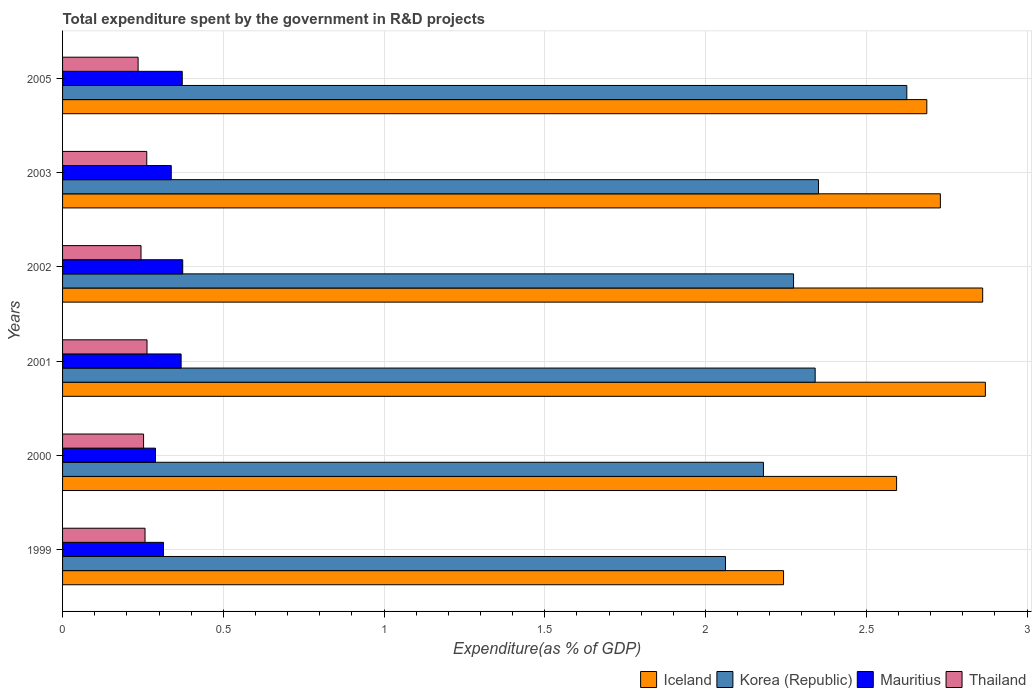How many groups of bars are there?
Offer a very short reply. 6. Are the number of bars per tick equal to the number of legend labels?
Offer a terse response. Yes. How many bars are there on the 1st tick from the top?
Your answer should be very brief. 4. How many bars are there on the 6th tick from the bottom?
Give a very brief answer. 4. What is the label of the 1st group of bars from the top?
Offer a terse response. 2005. In how many cases, is the number of bars for a given year not equal to the number of legend labels?
Give a very brief answer. 0. What is the total expenditure spent by the government in R&D projects in Iceland in 2003?
Provide a short and direct response. 2.73. Across all years, what is the maximum total expenditure spent by the government in R&D projects in Iceland?
Keep it short and to the point. 2.87. Across all years, what is the minimum total expenditure spent by the government in R&D projects in Thailand?
Provide a short and direct response. 0.23. In which year was the total expenditure spent by the government in R&D projects in Korea (Republic) minimum?
Provide a short and direct response. 1999. What is the total total expenditure spent by the government in R&D projects in Iceland in the graph?
Provide a succinct answer. 15.99. What is the difference between the total expenditure spent by the government in R&D projects in Korea (Republic) in 2001 and that in 2005?
Keep it short and to the point. -0.29. What is the difference between the total expenditure spent by the government in R&D projects in Thailand in 1999 and the total expenditure spent by the government in R&D projects in Korea (Republic) in 2002?
Provide a succinct answer. -2.02. What is the average total expenditure spent by the government in R&D projects in Mauritius per year?
Make the answer very short. 0.34. In the year 2000, what is the difference between the total expenditure spent by the government in R&D projects in Korea (Republic) and total expenditure spent by the government in R&D projects in Mauritius?
Make the answer very short. 1.89. In how many years, is the total expenditure spent by the government in R&D projects in Korea (Republic) greater than 1.3 %?
Keep it short and to the point. 6. What is the ratio of the total expenditure spent by the government in R&D projects in Thailand in 1999 to that in 2002?
Provide a short and direct response. 1.05. Is the total expenditure spent by the government in R&D projects in Korea (Republic) in 1999 less than that in 2005?
Give a very brief answer. Yes. Is the difference between the total expenditure spent by the government in R&D projects in Korea (Republic) in 2001 and 2002 greater than the difference between the total expenditure spent by the government in R&D projects in Mauritius in 2001 and 2002?
Your answer should be compact. Yes. What is the difference between the highest and the second highest total expenditure spent by the government in R&D projects in Mauritius?
Give a very brief answer. 0. What is the difference between the highest and the lowest total expenditure spent by the government in R&D projects in Iceland?
Provide a short and direct response. 0.63. Is the sum of the total expenditure spent by the government in R&D projects in Korea (Republic) in 2000 and 2002 greater than the maximum total expenditure spent by the government in R&D projects in Mauritius across all years?
Give a very brief answer. Yes. What does the 1st bar from the top in 1999 represents?
Offer a very short reply. Thailand. What does the 2nd bar from the bottom in 2002 represents?
Offer a terse response. Korea (Republic). Is it the case that in every year, the sum of the total expenditure spent by the government in R&D projects in Iceland and total expenditure spent by the government in R&D projects in Thailand is greater than the total expenditure spent by the government in R&D projects in Mauritius?
Your response must be concise. Yes. How many bars are there?
Provide a succinct answer. 24. How many years are there in the graph?
Offer a very short reply. 6. What is the difference between two consecutive major ticks on the X-axis?
Your answer should be compact. 0.5. Does the graph contain grids?
Your answer should be compact. Yes. What is the title of the graph?
Provide a short and direct response. Total expenditure spent by the government in R&D projects. Does "Barbados" appear as one of the legend labels in the graph?
Provide a succinct answer. No. What is the label or title of the X-axis?
Your response must be concise. Expenditure(as % of GDP). What is the label or title of the Y-axis?
Your answer should be compact. Years. What is the Expenditure(as % of GDP) in Iceland in 1999?
Your response must be concise. 2.24. What is the Expenditure(as % of GDP) in Korea (Republic) in 1999?
Give a very brief answer. 2.06. What is the Expenditure(as % of GDP) in Mauritius in 1999?
Make the answer very short. 0.31. What is the Expenditure(as % of GDP) in Thailand in 1999?
Offer a terse response. 0.26. What is the Expenditure(as % of GDP) in Iceland in 2000?
Give a very brief answer. 2.59. What is the Expenditure(as % of GDP) of Korea (Republic) in 2000?
Ensure brevity in your answer.  2.18. What is the Expenditure(as % of GDP) of Mauritius in 2000?
Your response must be concise. 0.29. What is the Expenditure(as % of GDP) of Thailand in 2000?
Ensure brevity in your answer.  0.25. What is the Expenditure(as % of GDP) in Iceland in 2001?
Your answer should be compact. 2.87. What is the Expenditure(as % of GDP) in Korea (Republic) in 2001?
Keep it short and to the point. 2.34. What is the Expenditure(as % of GDP) in Mauritius in 2001?
Offer a terse response. 0.37. What is the Expenditure(as % of GDP) of Thailand in 2001?
Your answer should be compact. 0.26. What is the Expenditure(as % of GDP) in Iceland in 2002?
Provide a short and direct response. 2.86. What is the Expenditure(as % of GDP) in Korea (Republic) in 2002?
Provide a succinct answer. 2.27. What is the Expenditure(as % of GDP) of Mauritius in 2002?
Your answer should be compact. 0.37. What is the Expenditure(as % of GDP) in Thailand in 2002?
Your answer should be compact. 0.24. What is the Expenditure(as % of GDP) in Iceland in 2003?
Offer a very short reply. 2.73. What is the Expenditure(as % of GDP) of Korea (Republic) in 2003?
Your answer should be very brief. 2.35. What is the Expenditure(as % of GDP) in Mauritius in 2003?
Ensure brevity in your answer.  0.34. What is the Expenditure(as % of GDP) of Thailand in 2003?
Ensure brevity in your answer.  0.26. What is the Expenditure(as % of GDP) in Iceland in 2005?
Keep it short and to the point. 2.69. What is the Expenditure(as % of GDP) in Korea (Republic) in 2005?
Your response must be concise. 2.63. What is the Expenditure(as % of GDP) in Mauritius in 2005?
Your answer should be compact. 0.37. What is the Expenditure(as % of GDP) in Thailand in 2005?
Provide a succinct answer. 0.23. Across all years, what is the maximum Expenditure(as % of GDP) of Iceland?
Your response must be concise. 2.87. Across all years, what is the maximum Expenditure(as % of GDP) in Korea (Republic)?
Your answer should be compact. 2.63. Across all years, what is the maximum Expenditure(as % of GDP) of Mauritius?
Keep it short and to the point. 0.37. Across all years, what is the maximum Expenditure(as % of GDP) in Thailand?
Keep it short and to the point. 0.26. Across all years, what is the minimum Expenditure(as % of GDP) of Iceland?
Ensure brevity in your answer.  2.24. Across all years, what is the minimum Expenditure(as % of GDP) in Korea (Republic)?
Offer a very short reply. 2.06. Across all years, what is the minimum Expenditure(as % of GDP) of Mauritius?
Keep it short and to the point. 0.29. Across all years, what is the minimum Expenditure(as % of GDP) of Thailand?
Offer a terse response. 0.23. What is the total Expenditure(as % of GDP) of Iceland in the graph?
Ensure brevity in your answer.  15.99. What is the total Expenditure(as % of GDP) in Korea (Republic) in the graph?
Ensure brevity in your answer.  13.83. What is the total Expenditure(as % of GDP) of Mauritius in the graph?
Provide a succinct answer. 2.06. What is the total Expenditure(as % of GDP) of Thailand in the graph?
Your answer should be very brief. 1.51. What is the difference between the Expenditure(as % of GDP) in Iceland in 1999 and that in 2000?
Ensure brevity in your answer.  -0.35. What is the difference between the Expenditure(as % of GDP) in Korea (Republic) in 1999 and that in 2000?
Ensure brevity in your answer.  -0.12. What is the difference between the Expenditure(as % of GDP) in Mauritius in 1999 and that in 2000?
Provide a short and direct response. 0.02. What is the difference between the Expenditure(as % of GDP) of Thailand in 1999 and that in 2000?
Make the answer very short. 0. What is the difference between the Expenditure(as % of GDP) in Iceland in 1999 and that in 2001?
Keep it short and to the point. -0.63. What is the difference between the Expenditure(as % of GDP) in Korea (Republic) in 1999 and that in 2001?
Make the answer very short. -0.28. What is the difference between the Expenditure(as % of GDP) of Mauritius in 1999 and that in 2001?
Provide a succinct answer. -0.05. What is the difference between the Expenditure(as % of GDP) in Thailand in 1999 and that in 2001?
Offer a very short reply. -0.01. What is the difference between the Expenditure(as % of GDP) of Iceland in 1999 and that in 2002?
Your answer should be compact. -0.62. What is the difference between the Expenditure(as % of GDP) in Korea (Republic) in 1999 and that in 2002?
Your answer should be very brief. -0.21. What is the difference between the Expenditure(as % of GDP) of Mauritius in 1999 and that in 2002?
Keep it short and to the point. -0.06. What is the difference between the Expenditure(as % of GDP) in Thailand in 1999 and that in 2002?
Provide a succinct answer. 0.01. What is the difference between the Expenditure(as % of GDP) in Iceland in 1999 and that in 2003?
Your answer should be compact. -0.49. What is the difference between the Expenditure(as % of GDP) in Korea (Republic) in 1999 and that in 2003?
Your answer should be compact. -0.29. What is the difference between the Expenditure(as % of GDP) in Mauritius in 1999 and that in 2003?
Your response must be concise. -0.02. What is the difference between the Expenditure(as % of GDP) of Thailand in 1999 and that in 2003?
Ensure brevity in your answer.  -0.01. What is the difference between the Expenditure(as % of GDP) in Iceland in 1999 and that in 2005?
Provide a short and direct response. -0.45. What is the difference between the Expenditure(as % of GDP) in Korea (Republic) in 1999 and that in 2005?
Offer a terse response. -0.56. What is the difference between the Expenditure(as % of GDP) in Mauritius in 1999 and that in 2005?
Your response must be concise. -0.06. What is the difference between the Expenditure(as % of GDP) of Thailand in 1999 and that in 2005?
Provide a succinct answer. 0.02. What is the difference between the Expenditure(as % of GDP) of Iceland in 2000 and that in 2001?
Provide a short and direct response. -0.28. What is the difference between the Expenditure(as % of GDP) of Korea (Republic) in 2000 and that in 2001?
Give a very brief answer. -0.16. What is the difference between the Expenditure(as % of GDP) of Mauritius in 2000 and that in 2001?
Offer a terse response. -0.08. What is the difference between the Expenditure(as % of GDP) in Thailand in 2000 and that in 2001?
Provide a short and direct response. -0.01. What is the difference between the Expenditure(as % of GDP) of Iceland in 2000 and that in 2002?
Provide a short and direct response. -0.27. What is the difference between the Expenditure(as % of GDP) in Korea (Republic) in 2000 and that in 2002?
Provide a succinct answer. -0.09. What is the difference between the Expenditure(as % of GDP) of Mauritius in 2000 and that in 2002?
Give a very brief answer. -0.08. What is the difference between the Expenditure(as % of GDP) of Thailand in 2000 and that in 2002?
Provide a short and direct response. 0.01. What is the difference between the Expenditure(as % of GDP) of Iceland in 2000 and that in 2003?
Make the answer very short. -0.14. What is the difference between the Expenditure(as % of GDP) in Korea (Republic) in 2000 and that in 2003?
Keep it short and to the point. -0.17. What is the difference between the Expenditure(as % of GDP) in Mauritius in 2000 and that in 2003?
Make the answer very short. -0.05. What is the difference between the Expenditure(as % of GDP) of Thailand in 2000 and that in 2003?
Offer a terse response. -0.01. What is the difference between the Expenditure(as % of GDP) of Iceland in 2000 and that in 2005?
Your answer should be compact. -0.09. What is the difference between the Expenditure(as % of GDP) in Korea (Republic) in 2000 and that in 2005?
Make the answer very short. -0.45. What is the difference between the Expenditure(as % of GDP) of Mauritius in 2000 and that in 2005?
Give a very brief answer. -0.08. What is the difference between the Expenditure(as % of GDP) of Thailand in 2000 and that in 2005?
Your answer should be compact. 0.02. What is the difference between the Expenditure(as % of GDP) of Iceland in 2001 and that in 2002?
Your answer should be compact. 0.01. What is the difference between the Expenditure(as % of GDP) of Korea (Republic) in 2001 and that in 2002?
Make the answer very short. 0.07. What is the difference between the Expenditure(as % of GDP) in Mauritius in 2001 and that in 2002?
Offer a very short reply. -0.01. What is the difference between the Expenditure(as % of GDP) of Thailand in 2001 and that in 2002?
Your response must be concise. 0.02. What is the difference between the Expenditure(as % of GDP) of Iceland in 2001 and that in 2003?
Keep it short and to the point. 0.14. What is the difference between the Expenditure(as % of GDP) in Korea (Republic) in 2001 and that in 2003?
Your response must be concise. -0.01. What is the difference between the Expenditure(as % of GDP) of Mauritius in 2001 and that in 2003?
Provide a short and direct response. 0.03. What is the difference between the Expenditure(as % of GDP) in Thailand in 2001 and that in 2003?
Offer a terse response. 0. What is the difference between the Expenditure(as % of GDP) of Iceland in 2001 and that in 2005?
Make the answer very short. 0.18. What is the difference between the Expenditure(as % of GDP) of Korea (Republic) in 2001 and that in 2005?
Give a very brief answer. -0.29. What is the difference between the Expenditure(as % of GDP) in Mauritius in 2001 and that in 2005?
Provide a succinct answer. -0. What is the difference between the Expenditure(as % of GDP) in Thailand in 2001 and that in 2005?
Provide a succinct answer. 0.03. What is the difference between the Expenditure(as % of GDP) in Iceland in 2002 and that in 2003?
Your answer should be compact. 0.13. What is the difference between the Expenditure(as % of GDP) in Korea (Republic) in 2002 and that in 2003?
Keep it short and to the point. -0.08. What is the difference between the Expenditure(as % of GDP) of Mauritius in 2002 and that in 2003?
Provide a succinct answer. 0.04. What is the difference between the Expenditure(as % of GDP) of Thailand in 2002 and that in 2003?
Provide a short and direct response. -0.02. What is the difference between the Expenditure(as % of GDP) of Iceland in 2002 and that in 2005?
Keep it short and to the point. 0.17. What is the difference between the Expenditure(as % of GDP) of Korea (Republic) in 2002 and that in 2005?
Provide a succinct answer. -0.35. What is the difference between the Expenditure(as % of GDP) of Mauritius in 2002 and that in 2005?
Offer a very short reply. 0. What is the difference between the Expenditure(as % of GDP) of Thailand in 2002 and that in 2005?
Keep it short and to the point. 0.01. What is the difference between the Expenditure(as % of GDP) in Iceland in 2003 and that in 2005?
Make the answer very short. 0.04. What is the difference between the Expenditure(as % of GDP) in Korea (Republic) in 2003 and that in 2005?
Ensure brevity in your answer.  -0.27. What is the difference between the Expenditure(as % of GDP) in Mauritius in 2003 and that in 2005?
Provide a short and direct response. -0.03. What is the difference between the Expenditure(as % of GDP) of Thailand in 2003 and that in 2005?
Give a very brief answer. 0.03. What is the difference between the Expenditure(as % of GDP) in Iceland in 1999 and the Expenditure(as % of GDP) in Korea (Republic) in 2000?
Keep it short and to the point. 0.06. What is the difference between the Expenditure(as % of GDP) of Iceland in 1999 and the Expenditure(as % of GDP) of Mauritius in 2000?
Offer a very short reply. 1.95. What is the difference between the Expenditure(as % of GDP) in Iceland in 1999 and the Expenditure(as % of GDP) in Thailand in 2000?
Ensure brevity in your answer.  1.99. What is the difference between the Expenditure(as % of GDP) in Korea (Republic) in 1999 and the Expenditure(as % of GDP) in Mauritius in 2000?
Offer a terse response. 1.77. What is the difference between the Expenditure(as % of GDP) in Korea (Republic) in 1999 and the Expenditure(as % of GDP) in Thailand in 2000?
Keep it short and to the point. 1.81. What is the difference between the Expenditure(as % of GDP) in Mauritius in 1999 and the Expenditure(as % of GDP) in Thailand in 2000?
Make the answer very short. 0.06. What is the difference between the Expenditure(as % of GDP) of Iceland in 1999 and the Expenditure(as % of GDP) of Korea (Republic) in 2001?
Give a very brief answer. -0.1. What is the difference between the Expenditure(as % of GDP) in Iceland in 1999 and the Expenditure(as % of GDP) in Mauritius in 2001?
Provide a short and direct response. 1.87. What is the difference between the Expenditure(as % of GDP) in Iceland in 1999 and the Expenditure(as % of GDP) in Thailand in 2001?
Ensure brevity in your answer.  1.98. What is the difference between the Expenditure(as % of GDP) in Korea (Republic) in 1999 and the Expenditure(as % of GDP) in Mauritius in 2001?
Your answer should be very brief. 1.69. What is the difference between the Expenditure(as % of GDP) in Korea (Republic) in 1999 and the Expenditure(as % of GDP) in Thailand in 2001?
Offer a very short reply. 1.8. What is the difference between the Expenditure(as % of GDP) in Mauritius in 1999 and the Expenditure(as % of GDP) in Thailand in 2001?
Keep it short and to the point. 0.05. What is the difference between the Expenditure(as % of GDP) of Iceland in 1999 and the Expenditure(as % of GDP) of Korea (Republic) in 2002?
Ensure brevity in your answer.  -0.03. What is the difference between the Expenditure(as % of GDP) of Iceland in 1999 and the Expenditure(as % of GDP) of Mauritius in 2002?
Offer a very short reply. 1.87. What is the difference between the Expenditure(as % of GDP) of Iceland in 1999 and the Expenditure(as % of GDP) of Thailand in 2002?
Ensure brevity in your answer.  2. What is the difference between the Expenditure(as % of GDP) of Korea (Republic) in 1999 and the Expenditure(as % of GDP) of Mauritius in 2002?
Provide a succinct answer. 1.69. What is the difference between the Expenditure(as % of GDP) in Korea (Republic) in 1999 and the Expenditure(as % of GDP) in Thailand in 2002?
Give a very brief answer. 1.82. What is the difference between the Expenditure(as % of GDP) in Mauritius in 1999 and the Expenditure(as % of GDP) in Thailand in 2002?
Offer a very short reply. 0.07. What is the difference between the Expenditure(as % of GDP) in Iceland in 1999 and the Expenditure(as % of GDP) in Korea (Republic) in 2003?
Keep it short and to the point. -0.11. What is the difference between the Expenditure(as % of GDP) of Iceland in 1999 and the Expenditure(as % of GDP) of Mauritius in 2003?
Offer a terse response. 1.9. What is the difference between the Expenditure(as % of GDP) in Iceland in 1999 and the Expenditure(as % of GDP) in Thailand in 2003?
Your answer should be very brief. 1.98. What is the difference between the Expenditure(as % of GDP) in Korea (Republic) in 1999 and the Expenditure(as % of GDP) in Mauritius in 2003?
Your answer should be compact. 1.72. What is the difference between the Expenditure(as % of GDP) in Korea (Republic) in 1999 and the Expenditure(as % of GDP) in Thailand in 2003?
Keep it short and to the point. 1.8. What is the difference between the Expenditure(as % of GDP) in Mauritius in 1999 and the Expenditure(as % of GDP) in Thailand in 2003?
Your response must be concise. 0.05. What is the difference between the Expenditure(as % of GDP) of Iceland in 1999 and the Expenditure(as % of GDP) of Korea (Republic) in 2005?
Offer a terse response. -0.38. What is the difference between the Expenditure(as % of GDP) in Iceland in 1999 and the Expenditure(as % of GDP) in Mauritius in 2005?
Your answer should be compact. 1.87. What is the difference between the Expenditure(as % of GDP) of Iceland in 1999 and the Expenditure(as % of GDP) of Thailand in 2005?
Offer a very short reply. 2.01. What is the difference between the Expenditure(as % of GDP) of Korea (Republic) in 1999 and the Expenditure(as % of GDP) of Mauritius in 2005?
Offer a terse response. 1.69. What is the difference between the Expenditure(as % of GDP) of Korea (Republic) in 1999 and the Expenditure(as % of GDP) of Thailand in 2005?
Ensure brevity in your answer.  1.83. What is the difference between the Expenditure(as % of GDP) in Mauritius in 1999 and the Expenditure(as % of GDP) in Thailand in 2005?
Your answer should be very brief. 0.08. What is the difference between the Expenditure(as % of GDP) in Iceland in 2000 and the Expenditure(as % of GDP) in Korea (Republic) in 2001?
Ensure brevity in your answer.  0.25. What is the difference between the Expenditure(as % of GDP) of Iceland in 2000 and the Expenditure(as % of GDP) of Mauritius in 2001?
Provide a short and direct response. 2.23. What is the difference between the Expenditure(as % of GDP) in Iceland in 2000 and the Expenditure(as % of GDP) in Thailand in 2001?
Your answer should be very brief. 2.33. What is the difference between the Expenditure(as % of GDP) of Korea (Republic) in 2000 and the Expenditure(as % of GDP) of Mauritius in 2001?
Your answer should be compact. 1.81. What is the difference between the Expenditure(as % of GDP) in Korea (Republic) in 2000 and the Expenditure(as % of GDP) in Thailand in 2001?
Ensure brevity in your answer.  1.92. What is the difference between the Expenditure(as % of GDP) in Mauritius in 2000 and the Expenditure(as % of GDP) in Thailand in 2001?
Your response must be concise. 0.03. What is the difference between the Expenditure(as % of GDP) of Iceland in 2000 and the Expenditure(as % of GDP) of Korea (Republic) in 2002?
Offer a terse response. 0.32. What is the difference between the Expenditure(as % of GDP) of Iceland in 2000 and the Expenditure(as % of GDP) of Mauritius in 2002?
Keep it short and to the point. 2.22. What is the difference between the Expenditure(as % of GDP) of Iceland in 2000 and the Expenditure(as % of GDP) of Thailand in 2002?
Give a very brief answer. 2.35. What is the difference between the Expenditure(as % of GDP) of Korea (Republic) in 2000 and the Expenditure(as % of GDP) of Mauritius in 2002?
Your response must be concise. 1.81. What is the difference between the Expenditure(as % of GDP) of Korea (Republic) in 2000 and the Expenditure(as % of GDP) of Thailand in 2002?
Provide a succinct answer. 1.94. What is the difference between the Expenditure(as % of GDP) of Mauritius in 2000 and the Expenditure(as % of GDP) of Thailand in 2002?
Provide a succinct answer. 0.04. What is the difference between the Expenditure(as % of GDP) of Iceland in 2000 and the Expenditure(as % of GDP) of Korea (Republic) in 2003?
Your answer should be compact. 0.24. What is the difference between the Expenditure(as % of GDP) in Iceland in 2000 and the Expenditure(as % of GDP) in Mauritius in 2003?
Your response must be concise. 2.26. What is the difference between the Expenditure(as % of GDP) of Iceland in 2000 and the Expenditure(as % of GDP) of Thailand in 2003?
Your answer should be very brief. 2.33. What is the difference between the Expenditure(as % of GDP) of Korea (Republic) in 2000 and the Expenditure(as % of GDP) of Mauritius in 2003?
Your answer should be very brief. 1.84. What is the difference between the Expenditure(as % of GDP) in Korea (Republic) in 2000 and the Expenditure(as % of GDP) in Thailand in 2003?
Your answer should be very brief. 1.92. What is the difference between the Expenditure(as % of GDP) in Mauritius in 2000 and the Expenditure(as % of GDP) in Thailand in 2003?
Make the answer very short. 0.03. What is the difference between the Expenditure(as % of GDP) in Iceland in 2000 and the Expenditure(as % of GDP) in Korea (Republic) in 2005?
Your answer should be compact. -0.03. What is the difference between the Expenditure(as % of GDP) in Iceland in 2000 and the Expenditure(as % of GDP) in Mauritius in 2005?
Offer a terse response. 2.22. What is the difference between the Expenditure(as % of GDP) of Iceland in 2000 and the Expenditure(as % of GDP) of Thailand in 2005?
Make the answer very short. 2.36. What is the difference between the Expenditure(as % of GDP) in Korea (Republic) in 2000 and the Expenditure(as % of GDP) in Mauritius in 2005?
Provide a succinct answer. 1.81. What is the difference between the Expenditure(as % of GDP) of Korea (Republic) in 2000 and the Expenditure(as % of GDP) of Thailand in 2005?
Offer a very short reply. 1.95. What is the difference between the Expenditure(as % of GDP) of Mauritius in 2000 and the Expenditure(as % of GDP) of Thailand in 2005?
Keep it short and to the point. 0.05. What is the difference between the Expenditure(as % of GDP) of Iceland in 2001 and the Expenditure(as % of GDP) of Korea (Republic) in 2002?
Keep it short and to the point. 0.6. What is the difference between the Expenditure(as % of GDP) of Iceland in 2001 and the Expenditure(as % of GDP) of Mauritius in 2002?
Your response must be concise. 2.5. What is the difference between the Expenditure(as % of GDP) in Iceland in 2001 and the Expenditure(as % of GDP) in Thailand in 2002?
Keep it short and to the point. 2.63. What is the difference between the Expenditure(as % of GDP) of Korea (Republic) in 2001 and the Expenditure(as % of GDP) of Mauritius in 2002?
Make the answer very short. 1.97. What is the difference between the Expenditure(as % of GDP) of Korea (Republic) in 2001 and the Expenditure(as % of GDP) of Thailand in 2002?
Make the answer very short. 2.1. What is the difference between the Expenditure(as % of GDP) of Mauritius in 2001 and the Expenditure(as % of GDP) of Thailand in 2002?
Offer a very short reply. 0.12. What is the difference between the Expenditure(as % of GDP) of Iceland in 2001 and the Expenditure(as % of GDP) of Korea (Republic) in 2003?
Your answer should be very brief. 0.52. What is the difference between the Expenditure(as % of GDP) in Iceland in 2001 and the Expenditure(as % of GDP) in Mauritius in 2003?
Provide a succinct answer. 2.53. What is the difference between the Expenditure(as % of GDP) in Iceland in 2001 and the Expenditure(as % of GDP) in Thailand in 2003?
Keep it short and to the point. 2.61. What is the difference between the Expenditure(as % of GDP) in Korea (Republic) in 2001 and the Expenditure(as % of GDP) in Mauritius in 2003?
Provide a succinct answer. 2. What is the difference between the Expenditure(as % of GDP) in Korea (Republic) in 2001 and the Expenditure(as % of GDP) in Thailand in 2003?
Provide a succinct answer. 2.08. What is the difference between the Expenditure(as % of GDP) of Mauritius in 2001 and the Expenditure(as % of GDP) of Thailand in 2003?
Your response must be concise. 0.11. What is the difference between the Expenditure(as % of GDP) of Iceland in 2001 and the Expenditure(as % of GDP) of Korea (Republic) in 2005?
Your answer should be very brief. 0.24. What is the difference between the Expenditure(as % of GDP) of Iceland in 2001 and the Expenditure(as % of GDP) of Mauritius in 2005?
Give a very brief answer. 2.5. What is the difference between the Expenditure(as % of GDP) of Iceland in 2001 and the Expenditure(as % of GDP) of Thailand in 2005?
Provide a short and direct response. 2.64. What is the difference between the Expenditure(as % of GDP) in Korea (Republic) in 2001 and the Expenditure(as % of GDP) in Mauritius in 2005?
Keep it short and to the point. 1.97. What is the difference between the Expenditure(as % of GDP) of Korea (Republic) in 2001 and the Expenditure(as % of GDP) of Thailand in 2005?
Give a very brief answer. 2.11. What is the difference between the Expenditure(as % of GDP) of Mauritius in 2001 and the Expenditure(as % of GDP) of Thailand in 2005?
Make the answer very short. 0.13. What is the difference between the Expenditure(as % of GDP) of Iceland in 2002 and the Expenditure(as % of GDP) of Korea (Republic) in 2003?
Provide a short and direct response. 0.51. What is the difference between the Expenditure(as % of GDP) of Iceland in 2002 and the Expenditure(as % of GDP) of Mauritius in 2003?
Your response must be concise. 2.52. What is the difference between the Expenditure(as % of GDP) in Iceland in 2002 and the Expenditure(as % of GDP) in Thailand in 2003?
Your response must be concise. 2.6. What is the difference between the Expenditure(as % of GDP) of Korea (Republic) in 2002 and the Expenditure(as % of GDP) of Mauritius in 2003?
Offer a very short reply. 1.94. What is the difference between the Expenditure(as % of GDP) in Korea (Republic) in 2002 and the Expenditure(as % of GDP) in Thailand in 2003?
Ensure brevity in your answer.  2.01. What is the difference between the Expenditure(as % of GDP) in Mauritius in 2002 and the Expenditure(as % of GDP) in Thailand in 2003?
Your answer should be compact. 0.11. What is the difference between the Expenditure(as % of GDP) in Iceland in 2002 and the Expenditure(as % of GDP) in Korea (Republic) in 2005?
Offer a terse response. 0.24. What is the difference between the Expenditure(as % of GDP) of Iceland in 2002 and the Expenditure(as % of GDP) of Mauritius in 2005?
Provide a succinct answer. 2.49. What is the difference between the Expenditure(as % of GDP) in Iceland in 2002 and the Expenditure(as % of GDP) in Thailand in 2005?
Your response must be concise. 2.63. What is the difference between the Expenditure(as % of GDP) in Korea (Republic) in 2002 and the Expenditure(as % of GDP) in Mauritius in 2005?
Your response must be concise. 1.9. What is the difference between the Expenditure(as % of GDP) in Korea (Republic) in 2002 and the Expenditure(as % of GDP) in Thailand in 2005?
Provide a succinct answer. 2.04. What is the difference between the Expenditure(as % of GDP) in Mauritius in 2002 and the Expenditure(as % of GDP) in Thailand in 2005?
Ensure brevity in your answer.  0.14. What is the difference between the Expenditure(as % of GDP) in Iceland in 2003 and the Expenditure(as % of GDP) in Korea (Republic) in 2005?
Your answer should be very brief. 0.1. What is the difference between the Expenditure(as % of GDP) of Iceland in 2003 and the Expenditure(as % of GDP) of Mauritius in 2005?
Your answer should be compact. 2.36. What is the difference between the Expenditure(as % of GDP) of Iceland in 2003 and the Expenditure(as % of GDP) of Thailand in 2005?
Give a very brief answer. 2.5. What is the difference between the Expenditure(as % of GDP) in Korea (Republic) in 2003 and the Expenditure(as % of GDP) in Mauritius in 2005?
Ensure brevity in your answer.  1.98. What is the difference between the Expenditure(as % of GDP) of Korea (Republic) in 2003 and the Expenditure(as % of GDP) of Thailand in 2005?
Offer a very short reply. 2.12. What is the difference between the Expenditure(as % of GDP) of Mauritius in 2003 and the Expenditure(as % of GDP) of Thailand in 2005?
Your response must be concise. 0.1. What is the average Expenditure(as % of GDP) in Iceland per year?
Keep it short and to the point. 2.66. What is the average Expenditure(as % of GDP) of Korea (Republic) per year?
Your answer should be compact. 2.31. What is the average Expenditure(as % of GDP) of Mauritius per year?
Provide a succinct answer. 0.34. What is the average Expenditure(as % of GDP) of Thailand per year?
Offer a very short reply. 0.25. In the year 1999, what is the difference between the Expenditure(as % of GDP) in Iceland and Expenditure(as % of GDP) in Korea (Republic)?
Provide a short and direct response. 0.18. In the year 1999, what is the difference between the Expenditure(as % of GDP) of Iceland and Expenditure(as % of GDP) of Mauritius?
Make the answer very short. 1.93. In the year 1999, what is the difference between the Expenditure(as % of GDP) in Iceland and Expenditure(as % of GDP) in Thailand?
Your response must be concise. 1.99. In the year 1999, what is the difference between the Expenditure(as % of GDP) of Korea (Republic) and Expenditure(as % of GDP) of Mauritius?
Keep it short and to the point. 1.75. In the year 1999, what is the difference between the Expenditure(as % of GDP) of Korea (Republic) and Expenditure(as % of GDP) of Thailand?
Offer a terse response. 1.81. In the year 1999, what is the difference between the Expenditure(as % of GDP) in Mauritius and Expenditure(as % of GDP) in Thailand?
Ensure brevity in your answer.  0.06. In the year 2000, what is the difference between the Expenditure(as % of GDP) of Iceland and Expenditure(as % of GDP) of Korea (Republic)?
Keep it short and to the point. 0.41. In the year 2000, what is the difference between the Expenditure(as % of GDP) of Iceland and Expenditure(as % of GDP) of Mauritius?
Provide a succinct answer. 2.31. In the year 2000, what is the difference between the Expenditure(as % of GDP) of Iceland and Expenditure(as % of GDP) of Thailand?
Give a very brief answer. 2.34. In the year 2000, what is the difference between the Expenditure(as % of GDP) in Korea (Republic) and Expenditure(as % of GDP) in Mauritius?
Offer a very short reply. 1.89. In the year 2000, what is the difference between the Expenditure(as % of GDP) of Korea (Republic) and Expenditure(as % of GDP) of Thailand?
Give a very brief answer. 1.93. In the year 2000, what is the difference between the Expenditure(as % of GDP) of Mauritius and Expenditure(as % of GDP) of Thailand?
Offer a very short reply. 0.04. In the year 2001, what is the difference between the Expenditure(as % of GDP) in Iceland and Expenditure(as % of GDP) in Korea (Republic)?
Your response must be concise. 0.53. In the year 2001, what is the difference between the Expenditure(as % of GDP) of Iceland and Expenditure(as % of GDP) of Mauritius?
Your response must be concise. 2.5. In the year 2001, what is the difference between the Expenditure(as % of GDP) in Iceland and Expenditure(as % of GDP) in Thailand?
Your answer should be very brief. 2.61. In the year 2001, what is the difference between the Expenditure(as % of GDP) of Korea (Republic) and Expenditure(as % of GDP) of Mauritius?
Make the answer very short. 1.97. In the year 2001, what is the difference between the Expenditure(as % of GDP) in Korea (Republic) and Expenditure(as % of GDP) in Thailand?
Provide a succinct answer. 2.08. In the year 2001, what is the difference between the Expenditure(as % of GDP) in Mauritius and Expenditure(as % of GDP) in Thailand?
Offer a terse response. 0.11. In the year 2002, what is the difference between the Expenditure(as % of GDP) of Iceland and Expenditure(as % of GDP) of Korea (Republic)?
Offer a terse response. 0.59. In the year 2002, what is the difference between the Expenditure(as % of GDP) of Iceland and Expenditure(as % of GDP) of Mauritius?
Make the answer very short. 2.49. In the year 2002, what is the difference between the Expenditure(as % of GDP) in Iceland and Expenditure(as % of GDP) in Thailand?
Provide a succinct answer. 2.62. In the year 2002, what is the difference between the Expenditure(as % of GDP) of Korea (Republic) and Expenditure(as % of GDP) of Mauritius?
Your answer should be compact. 1.9. In the year 2002, what is the difference between the Expenditure(as % of GDP) in Korea (Republic) and Expenditure(as % of GDP) in Thailand?
Your response must be concise. 2.03. In the year 2002, what is the difference between the Expenditure(as % of GDP) in Mauritius and Expenditure(as % of GDP) in Thailand?
Your answer should be compact. 0.13. In the year 2003, what is the difference between the Expenditure(as % of GDP) in Iceland and Expenditure(as % of GDP) in Korea (Republic)?
Your answer should be compact. 0.38. In the year 2003, what is the difference between the Expenditure(as % of GDP) in Iceland and Expenditure(as % of GDP) in Mauritius?
Provide a short and direct response. 2.39. In the year 2003, what is the difference between the Expenditure(as % of GDP) of Iceland and Expenditure(as % of GDP) of Thailand?
Give a very brief answer. 2.47. In the year 2003, what is the difference between the Expenditure(as % of GDP) in Korea (Republic) and Expenditure(as % of GDP) in Mauritius?
Offer a terse response. 2.01. In the year 2003, what is the difference between the Expenditure(as % of GDP) in Korea (Republic) and Expenditure(as % of GDP) in Thailand?
Provide a succinct answer. 2.09. In the year 2003, what is the difference between the Expenditure(as % of GDP) in Mauritius and Expenditure(as % of GDP) in Thailand?
Offer a terse response. 0.08. In the year 2005, what is the difference between the Expenditure(as % of GDP) of Iceland and Expenditure(as % of GDP) of Korea (Republic)?
Make the answer very short. 0.06. In the year 2005, what is the difference between the Expenditure(as % of GDP) of Iceland and Expenditure(as % of GDP) of Mauritius?
Offer a very short reply. 2.32. In the year 2005, what is the difference between the Expenditure(as % of GDP) in Iceland and Expenditure(as % of GDP) in Thailand?
Keep it short and to the point. 2.45. In the year 2005, what is the difference between the Expenditure(as % of GDP) in Korea (Republic) and Expenditure(as % of GDP) in Mauritius?
Give a very brief answer. 2.25. In the year 2005, what is the difference between the Expenditure(as % of GDP) in Korea (Republic) and Expenditure(as % of GDP) in Thailand?
Your answer should be very brief. 2.39. In the year 2005, what is the difference between the Expenditure(as % of GDP) of Mauritius and Expenditure(as % of GDP) of Thailand?
Ensure brevity in your answer.  0.14. What is the ratio of the Expenditure(as % of GDP) of Iceland in 1999 to that in 2000?
Give a very brief answer. 0.86. What is the ratio of the Expenditure(as % of GDP) in Korea (Republic) in 1999 to that in 2000?
Offer a terse response. 0.95. What is the ratio of the Expenditure(as % of GDP) in Mauritius in 1999 to that in 2000?
Give a very brief answer. 1.09. What is the ratio of the Expenditure(as % of GDP) in Thailand in 1999 to that in 2000?
Give a very brief answer. 1.02. What is the ratio of the Expenditure(as % of GDP) in Iceland in 1999 to that in 2001?
Give a very brief answer. 0.78. What is the ratio of the Expenditure(as % of GDP) of Korea (Republic) in 1999 to that in 2001?
Your response must be concise. 0.88. What is the ratio of the Expenditure(as % of GDP) of Mauritius in 1999 to that in 2001?
Offer a very short reply. 0.85. What is the ratio of the Expenditure(as % of GDP) in Thailand in 1999 to that in 2001?
Your response must be concise. 0.98. What is the ratio of the Expenditure(as % of GDP) of Iceland in 1999 to that in 2002?
Keep it short and to the point. 0.78. What is the ratio of the Expenditure(as % of GDP) of Korea (Republic) in 1999 to that in 2002?
Your answer should be very brief. 0.91. What is the ratio of the Expenditure(as % of GDP) in Mauritius in 1999 to that in 2002?
Keep it short and to the point. 0.84. What is the ratio of the Expenditure(as % of GDP) in Thailand in 1999 to that in 2002?
Your response must be concise. 1.05. What is the ratio of the Expenditure(as % of GDP) in Iceland in 1999 to that in 2003?
Provide a succinct answer. 0.82. What is the ratio of the Expenditure(as % of GDP) in Korea (Republic) in 1999 to that in 2003?
Your answer should be compact. 0.88. What is the ratio of the Expenditure(as % of GDP) of Mauritius in 1999 to that in 2003?
Give a very brief answer. 0.93. What is the ratio of the Expenditure(as % of GDP) in Thailand in 1999 to that in 2003?
Your answer should be very brief. 0.98. What is the ratio of the Expenditure(as % of GDP) in Iceland in 1999 to that in 2005?
Your response must be concise. 0.83. What is the ratio of the Expenditure(as % of GDP) of Korea (Republic) in 1999 to that in 2005?
Offer a terse response. 0.79. What is the ratio of the Expenditure(as % of GDP) of Mauritius in 1999 to that in 2005?
Provide a succinct answer. 0.84. What is the ratio of the Expenditure(as % of GDP) in Thailand in 1999 to that in 2005?
Give a very brief answer. 1.09. What is the ratio of the Expenditure(as % of GDP) in Iceland in 2000 to that in 2001?
Your answer should be compact. 0.9. What is the ratio of the Expenditure(as % of GDP) of Korea (Republic) in 2000 to that in 2001?
Your response must be concise. 0.93. What is the ratio of the Expenditure(as % of GDP) of Mauritius in 2000 to that in 2001?
Your answer should be very brief. 0.78. What is the ratio of the Expenditure(as % of GDP) of Thailand in 2000 to that in 2001?
Provide a short and direct response. 0.96. What is the ratio of the Expenditure(as % of GDP) of Iceland in 2000 to that in 2002?
Ensure brevity in your answer.  0.91. What is the ratio of the Expenditure(as % of GDP) of Korea (Republic) in 2000 to that in 2002?
Your answer should be very brief. 0.96. What is the ratio of the Expenditure(as % of GDP) of Mauritius in 2000 to that in 2002?
Your answer should be compact. 0.77. What is the ratio of the Expenditure(as % of GDP) of Thailand in 2000 to that in 2002?
Your answer should be compact. 1.03. What is the ratio of the Expenditure(as % of GDP) of Iceland in 2000 to that in 2003?
Provide a short and direct response. 0.95. What is the ratio of the Expenditure(as % of GDP) of Korea (Republic) in 2000 to that in 2003?
Your response must be concise. 0.93. What is the ratio of the Expenditure(as % of GDP) in Mauritius in 2000 to that in 2003?
Provide a succinct answer. 0.85. What is the ratio of the Expenditure(as % of GDP) in Thailand in 2000 to that in 2003?
Keep it short and to the point. 0.96. What is the ratio of the Expenditure(as % of GDP) of Iceland in 2000 to that in 2005?
Your answer should be compact. 0.96. What is the ratio of the Expenditure(as % of GDP) of Korea (Republic) in 2000 to that in 2005?
Offer a very short reply. 0.83. What is the ratio of the Expenditure(as % of GDP) in Mauritius in 2000 to that in 2005?
Provide a succinct answer. 0.78. What is the ratio of the Expenditure(as % of GDP) in Thailand in 2000 to that in 2005?
Keep it short and to the point. 1.07. What is the ratio of the Expenditure(as % of GDP) of Iceland in 2001 to that in 2002?
Ensure brevity in your answer.  1. What is the ratio of the Expenditure(as % of GDP) of Korea (Republic) in 2001 to that in 2002?
Offer a terse response. 1.03. What is the ratio of the Expenditure(as % of GDP) of Mauritius in 2001 to that in 2002?
Offer a terse response. 0.99. What is the ratio of the Expenditure(as % of GDP) of Thailand in 2001 to that in 2002?
Offer a terse response. 1.08. What is the ratio of the Expenditure(as % of GDP) of Iceland in 2001 to that in 2003?
Offer a very short reply. 1.05. What is the ratio of the Expenditure(as % of GDP) of Korea (Republic) in 2001 to that in 2003?
Your response must be concise. 1. What is the ratio of the Expenditure(as % of GDP) of Mauritius in 2001 to that in 2003?
Ensure brevity in your answer.  1.09. What is the ratio of the Expenditure(as % of GDP) of Thailand in 2001 to that in 2003?
Provide a succinct answer. 1. What is the ratio of the Expenditure(as % of GDP) in Iceland in 2001 to that in 2005?
Make the answer very short. 1.07. What is the ratio of the Expenditure(as % of GDP) of Korea (Republic) in 2001 to that in 2005?
Provide a succinct answer. 0.89. What is the ratio of the Expenditure(as % of GDP) of Mauritius in 2001 to that in 2005?
Offer a terse response. 0.99. What is the ratio of the Expenditure(as % of GDP) in Thailand in 2001 to that in 2005?
Provide a succinct answer. 1.12. What is the ratio of the Expenditure(as % of GDP) of Iceland in 2002 to that in 2003?
Make the answer very short. 1.05. What is the ratio of the Expenditure(as % of GDP) in Korea (Republic) in 2002 to that in 2003?
Provide a short and direct response. 0.97. What is the ratio of the Expenditure(as % of GDP) in Mauritius in 2002 to that in 2003?
Provide a succinct answer. 1.11. What is the ratio of the Expenditure(as % of GDP) of Thailand in 2002 to that in 2003?
Provide a succinct answer. 0.93. What is the ratio of the Expenditure(as % of GDP) of Iceland in 2002 to that in 2005?
Ensure brevity in your answer.  1.06. What is the ratio of the Expenditure(as % of GDP) in Korea (Republic) in 2002 to that in 2005?
Ensure brevity in your answer.  0.87. What is the ratio of the Expenditure(as % of GDP) of Thailand in 2002 to that in 2005?
Keep it short and to the point. 1.04. What is the ratio of the Expenditure(as % of GDP) in Iceland in 2003 to that in 2005?
Your answer should be compact. 1.02. What is the ratio of the Expenditure(as % of GDP) of Korea (Republic) in 2003 to that in 2005?
Keep it short and to the point. 0.9. What is the ratio of the Expenditure(as % of GDP) of Mauritius in 2003 to that in 2005?
Give a very brief answer. 0.91. What is the ratio of the Expenditure(as % of GDP) of Thailand in 2003 to that in 2005?
Your answer should be very brief. 1.11. What is the difference between the highest and the second highest Expenditure(as % of GDP) in Iceland?
Give a very brief answer. 0.01. What is the difference between the highest and the second highest Expenditure(as % of GDP) in Korea (Republic)?
Offer a terse response. 0.27. What is the difference between the highest and the second highest Expenditure(as % of GDP) in Mauritius?
Your answer should be compact. 0. What is the difference between the highest and the second highest Expenditure(as % of GDP) in Thailand?
Offer a very short reply. 0. What is the difference between the highest and the lowest Expenditure(as % of GDP) of Iceland?
Give a very brief answer. 0.63. What is the difference between the highest and the lowest Expenditure(as % of GDP) in Korea (Republic)?
Keep it short and to the point. 0.56. What is the difference between the highest and the lowest Expenditure(as % of GDP) in Mauritius?
Your answer should be compact. 0.08. What is the difference between the highest and the lowest Expenditure(as % of GDP) of Thailand?
Keep it short and to the point. 0.03. 